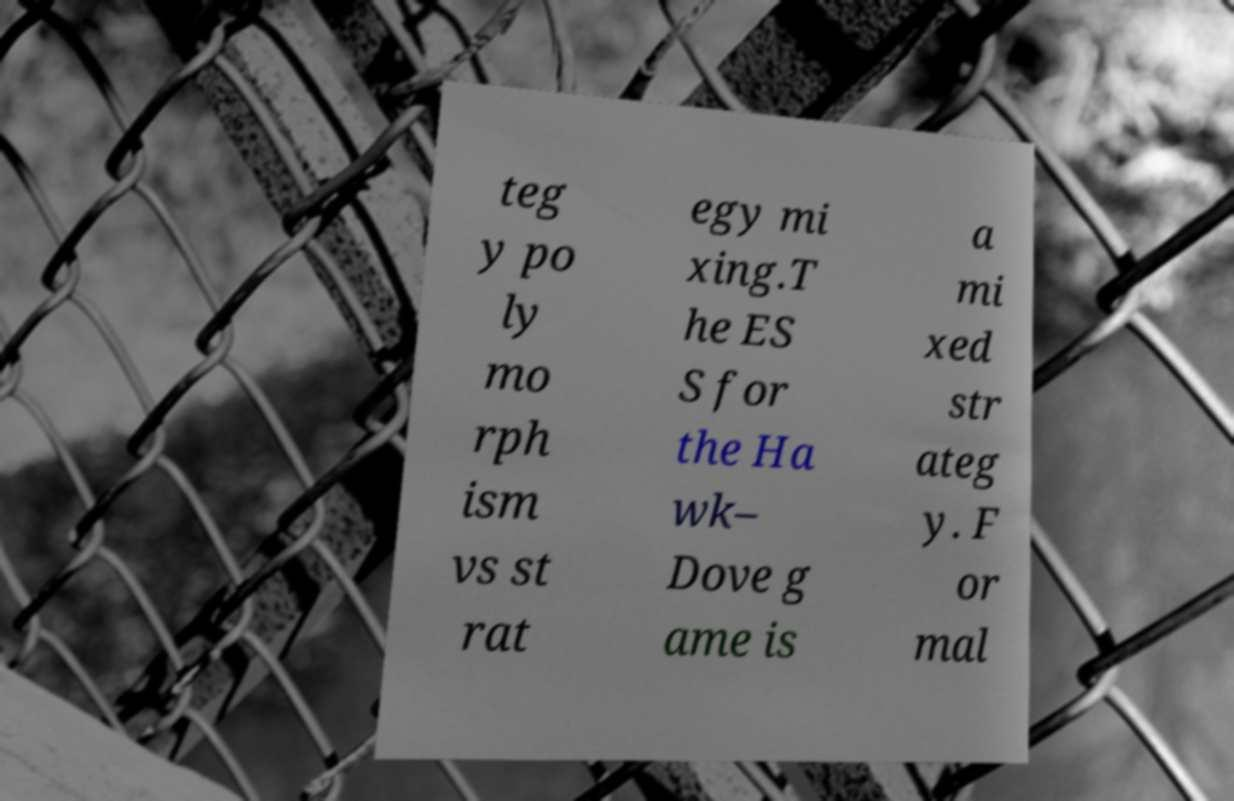Could you assist in decoding the text presented in this image and type it out clearly? teg y po ly mo rph ism vs st rat egy mi xing.T he ES S for the Ha wk– Dove g ame is a mi xed str ateg y. F or mal 